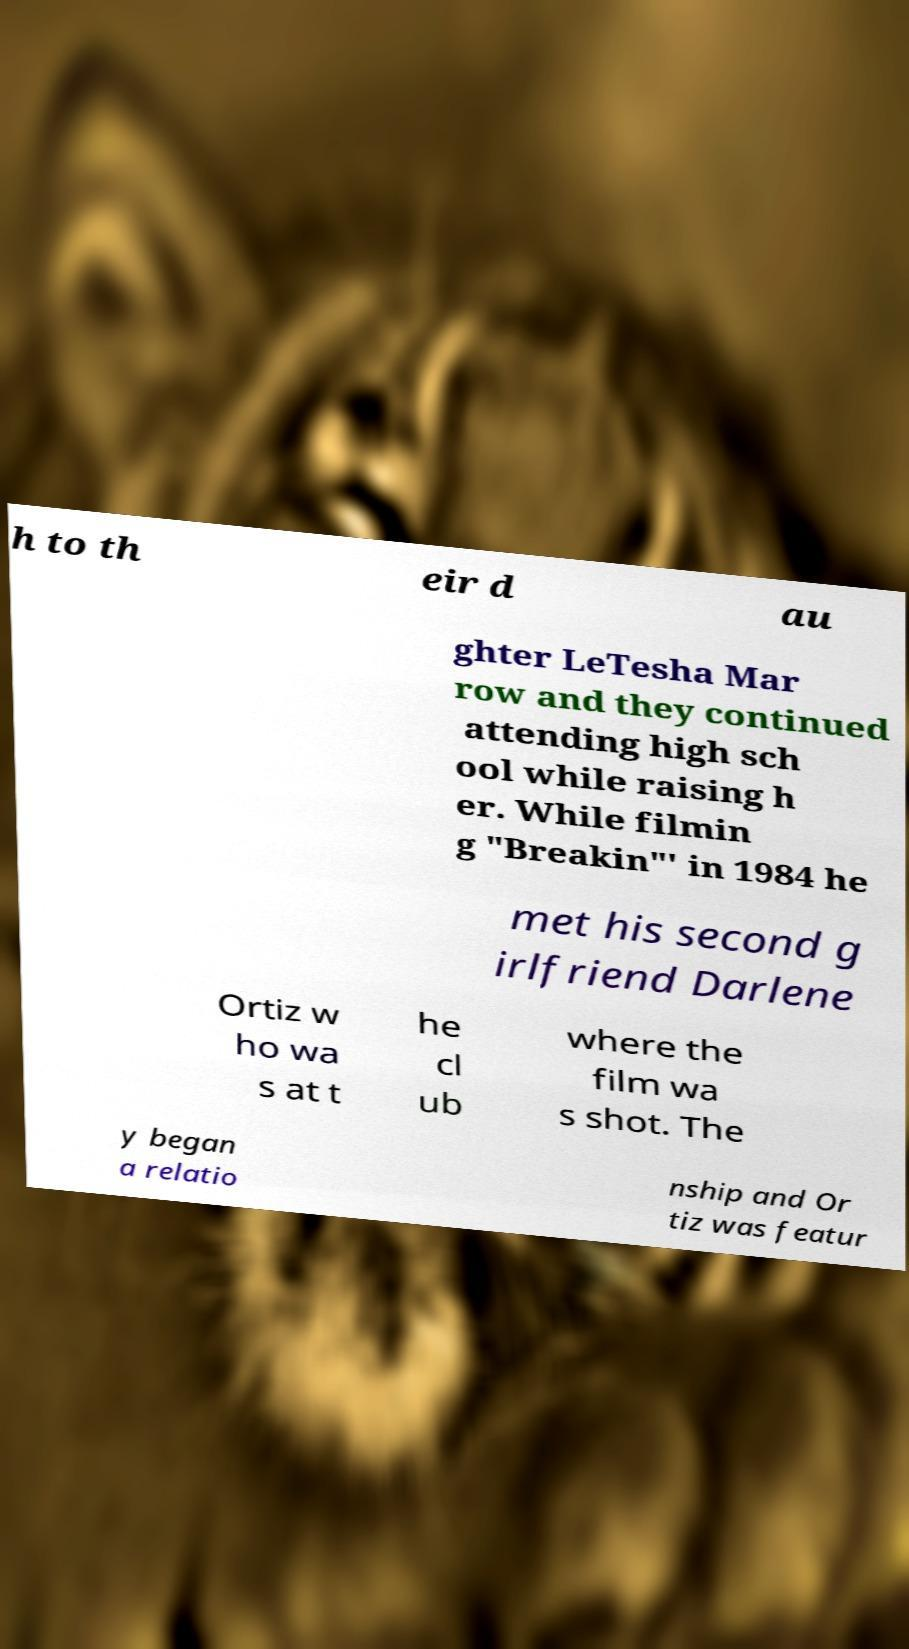Could you extract and type out the text from this image? h to th eir d au ghter LeTesha Mar row and they continued attending high sch ool while raising h er. While filmin g "Breakin"' in 1984 he met his second g irlfriend Darlene Ortiz w ho wa s at t he cl ub where the film wa s shot. The y began a relatio nship and Or tiz was featur 